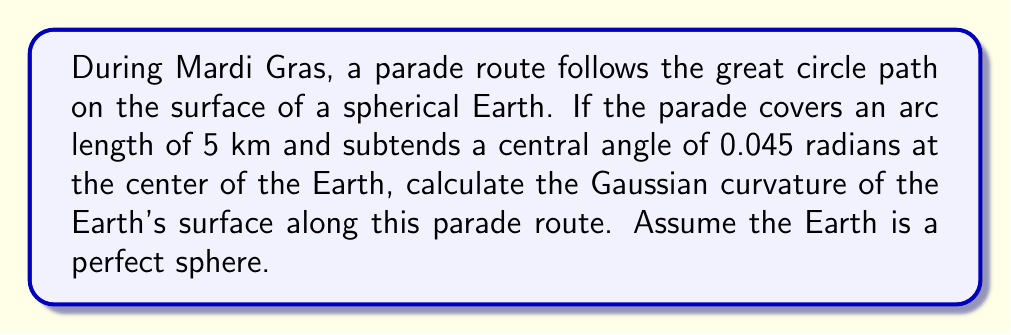Can you answer this question? Let's approach this step-by-step:

1) The Gaussian curvature ($K$) of a sphere is constant over its entire surface and is given by:

   $$K = \frac{1}{R^2}$$

   where $R$ is the radius of the sphere.

2) We need to find the radius of the Earth. We can use the relationship between arc length ($s$), radius ($R$), and central angle ($\theta$):

   $$s = R\theta$$

3) We are given:
   - Arc length ($s$) = 5 km = 5000 m
   - Central angle ($\theta$) = 0.045 radians

4) Substituting these into the arc length formula:

   $$5000 = R(0.045)$$

5) Solving for $R$:

   $$R = \frac{5000}{0.045} \approx 111,111.11 \text{ m}$$

6) Now that we have $R$, we can calculate the Gaussian curvature:

   $$K = \frac{1}{R^2} = \frac{1}{(111,111.11)^2} \approx 8.1 \times 10^{-11} \text{ m}^{-2}$$

Thus, the Gaussian curvature of the Earth's surface along the Mardi Gras parade route is approximately $8.1 \times 10^{-11} \text{ m}^{-2}$.
Answer: $8.1 \times 10^{-11} \text{ m}^{-2}$ 